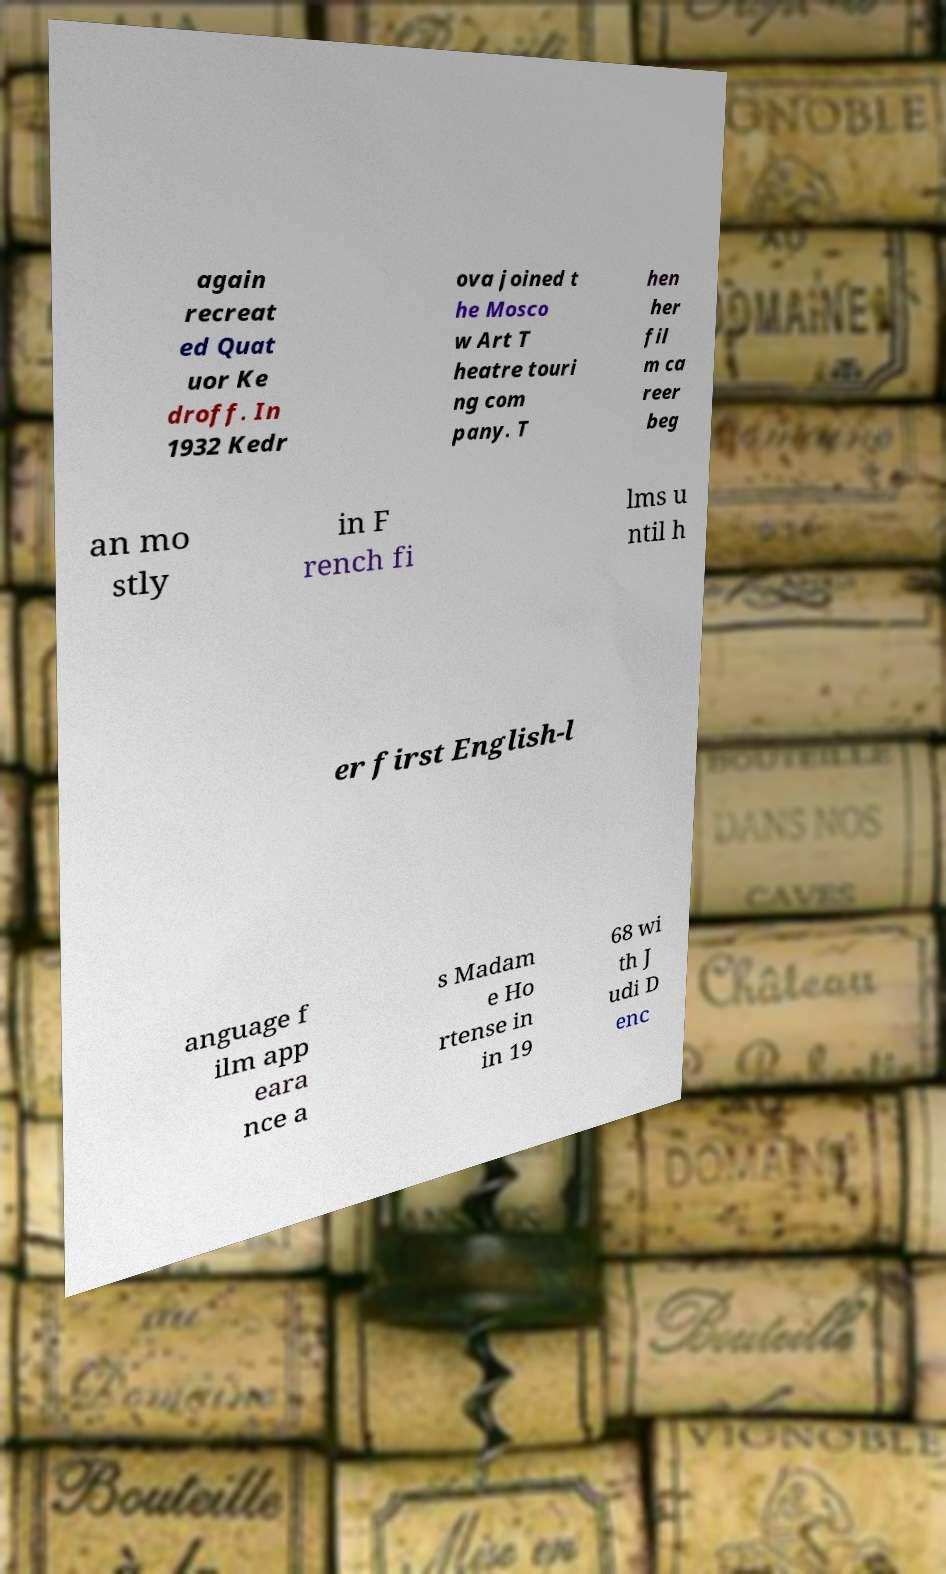Can you read and provide the text displayed in the image?This photo seems to have some interesting text. Can you extract and type it out for me? again recreat ed Quat uor Ke droff. In 1932 Kedr ova joined t he Mosco w Art T heatre touri ng com pany. T hen her fil m ca reer beg an mo stly in F rench fi lms u ntil h er first English-l anguage f ilm app eara nce a s Madam e Ho rtense in in 19 68 wi th J udi D enc 